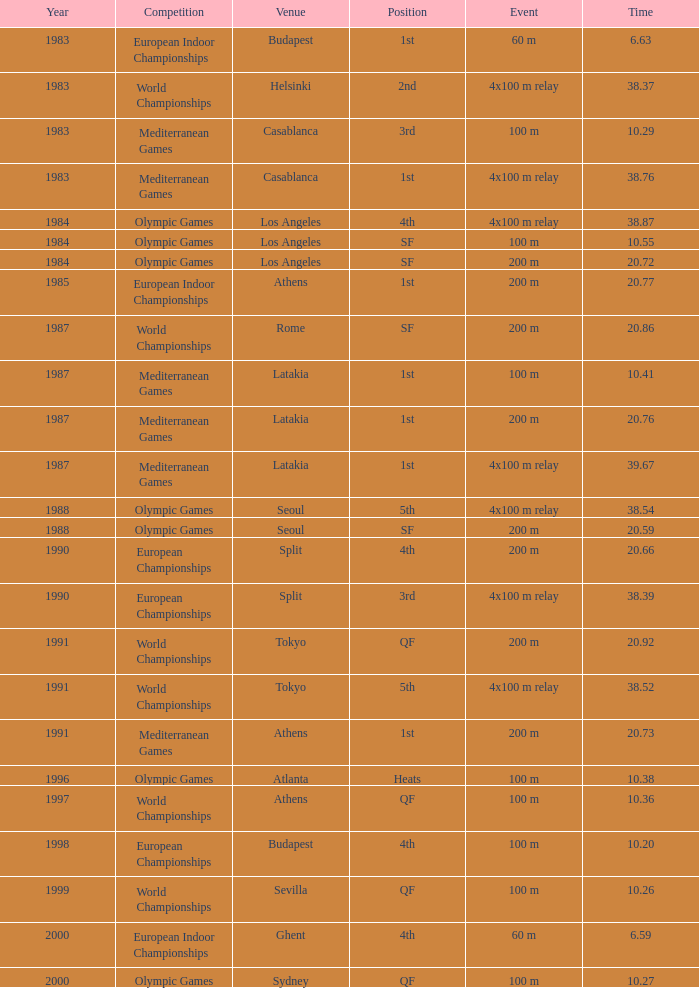What Position has a Time of 20.66? 4th. 